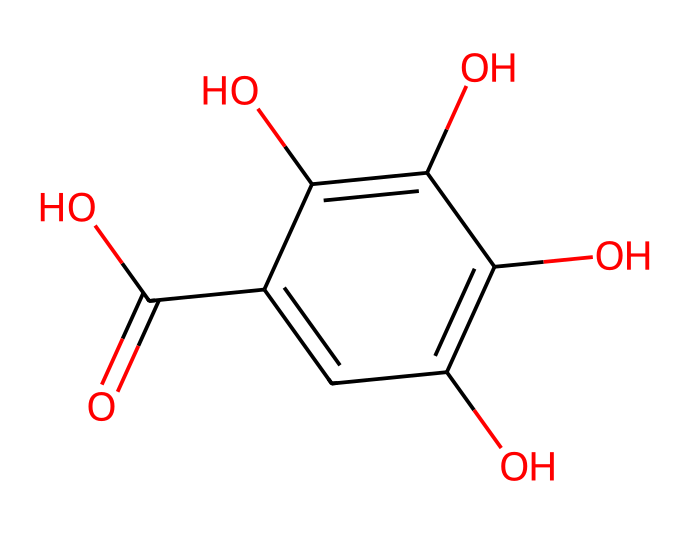what is the molecular formula of this compound? By analyzing the provided SMILES representation, we can identify the individual atoms present. Counting the number of carbon (C), hydrogen (H), and oxygen (O) atoms gives us C₇H₈O₅.
Answer: C7H8O5 how many hydroxyl (-OH) groups are present in the structure? We examine the structure for the presence of hydroxyl groups, identifiable by -OH units. In the given SMILES, there are three -OH groups attached to the aromatic ring.
Answer: 3 is this compound an acid or a base? From the structure, one can observe the presence of a carboxylic acid functional group (C(=O)O), indicating that the compound is acidic in nature.
Answer: acid what type of chemical is this compound categorized as? This compound has multiple hydroxyl and a carboxylic acid group, categorizing it as a phenolic compound.
Answer: phenolic how does the structure reflect photoreactive properties? The presence of a conjugated system of double bonds within the aromatic ring allows for excitation and reactivity under light, illustrating its photoreactive characteristics.
Answer: conjugated system which functional group predominantly contributes to the compound's acidity? The carboxylic acid functional group (C(=O)O) is identified as the key contributor to the compound's acidic nature by donating protons.
Answer: carboxylic acid 